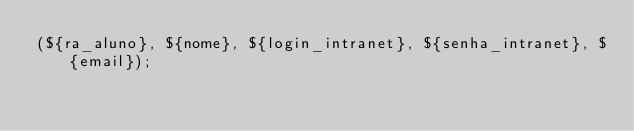<code> <loc_0><loc_0><loc_500><loc_500><_SQL_>(${ra_aluno}, ${nome}, ${login_intranet}, ${senha_intranet}, ${email});</code> 